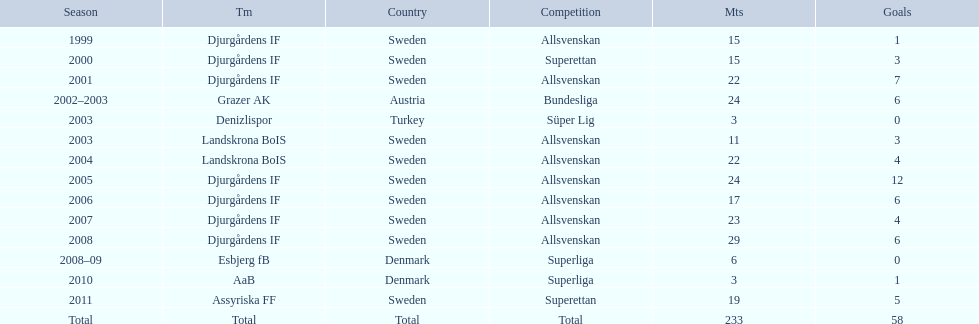How many teams had above 20 matches in the season? 6. 